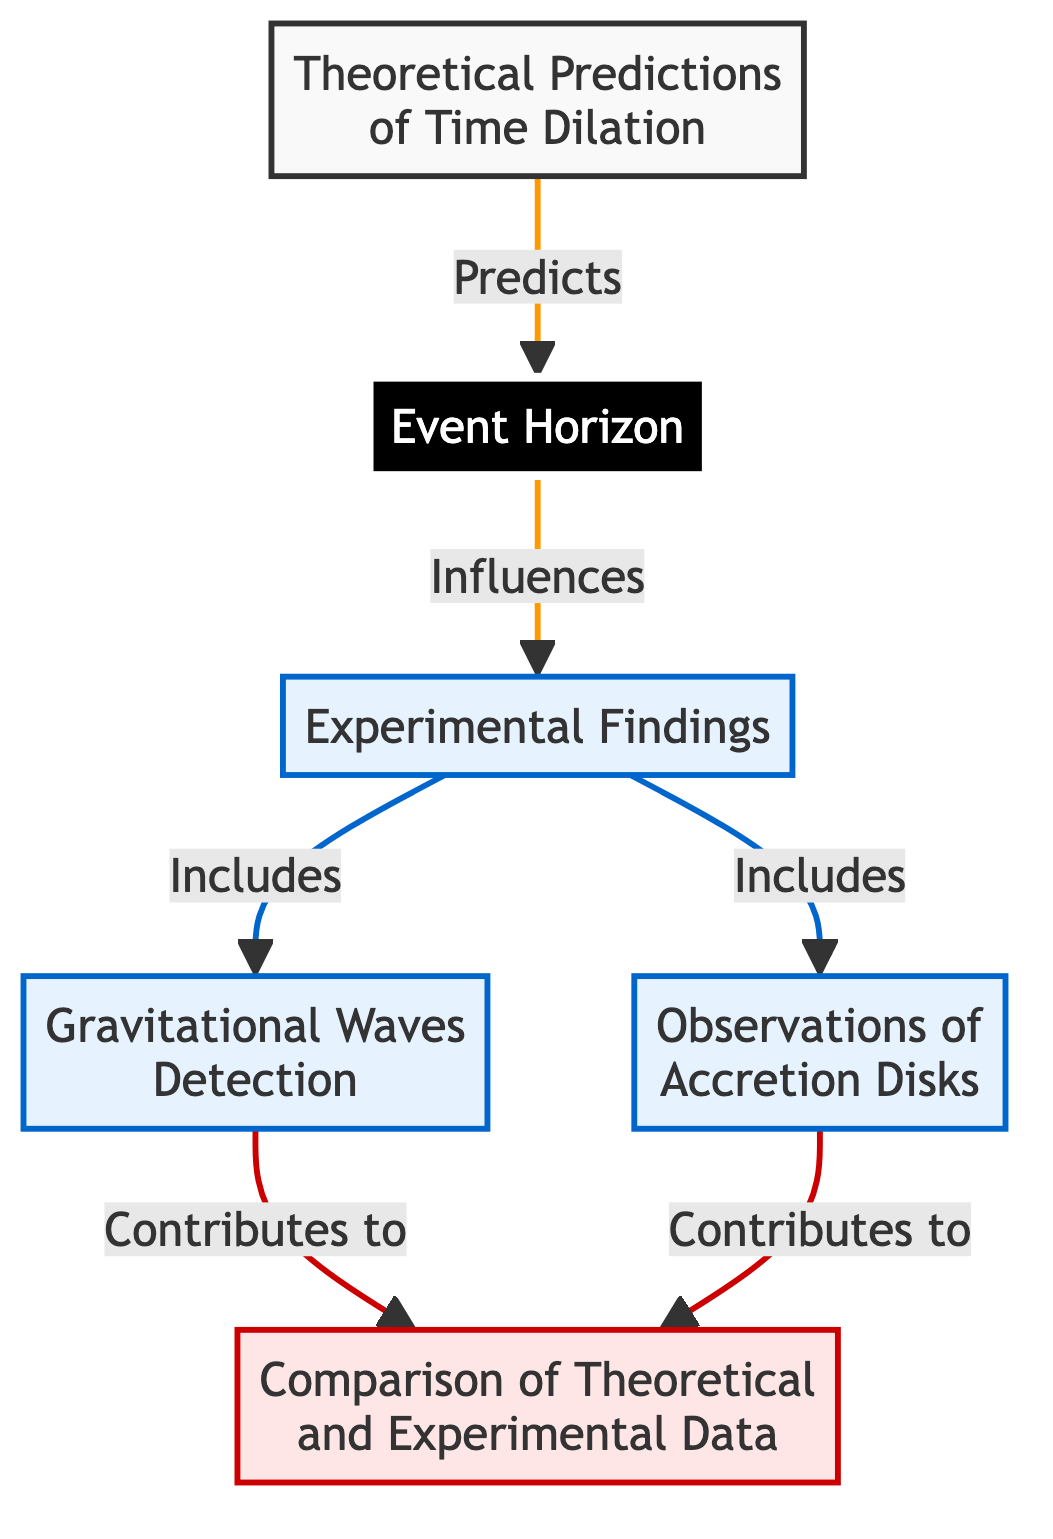What is the first node in the flow chart? The first node is labeled "Theoretical Predictions of Time Dilation." It is the starting point of the diagram.
Answer: Theoretical Predictions of Time Dilation How many edges are in the flow chart? By counting the connections from one node to another in the diagram, there are six edges connecting the nodes.
Answer: 6 What is the label of the node that describes the boundary of a black hole? The node that describes the boundary of a black hole is labeled "Event Horizon." It directly relates to the extreme time dilation effects occurring near black holes.
Answer: Event Horizon Which experimental finding includes gravitational wave detection? The experimental finding that includes gravitational wave detection is linked to the node labeled "Experimental Findings," which incorporates both gravitational waves and observations of accretion disks.
Answer: Gravitational Waves Detection What influences the node "Experimental Findings"? The node "Experimental Findings" is influenced by the node "Event Horizon," as it speaks to the effects observed due to time dilation near such boundaries.
Answer: Event Horizon What contributes to validating the data between theoretical and experimental findings? Both "Gravitational Waves Detection" and "Observations of Accretion Disks" contribute to the comparison of theoretical predictions and experimental findings, leading to validation or challenges of the theoretical models.
Answer: Gravitational Waves Detection and Observations of Accretion Disks Which nodes are classified as experimental findings? The nodes classified as experimental findings are "Gravitational Waves Detection" and "Observations of Accretion Disks," which both provide empirical data related to time dilation.
Answer: Gravitational Waves Detection, Observations of Accretion Disks What is the relationship between theoretical predictions and the event horizon? The relationship is that theoretical predictions provide the basis for understanding the extreme time dilation effects that occur at the event horizon of black holes.
Answer: Predicts How does the event horizon relate to experimental findings? The event horizon influences experimental findings, as it is the conceptual boundary where time dilation effects are significant and observable in astrophysical data.
Answer: Influences 